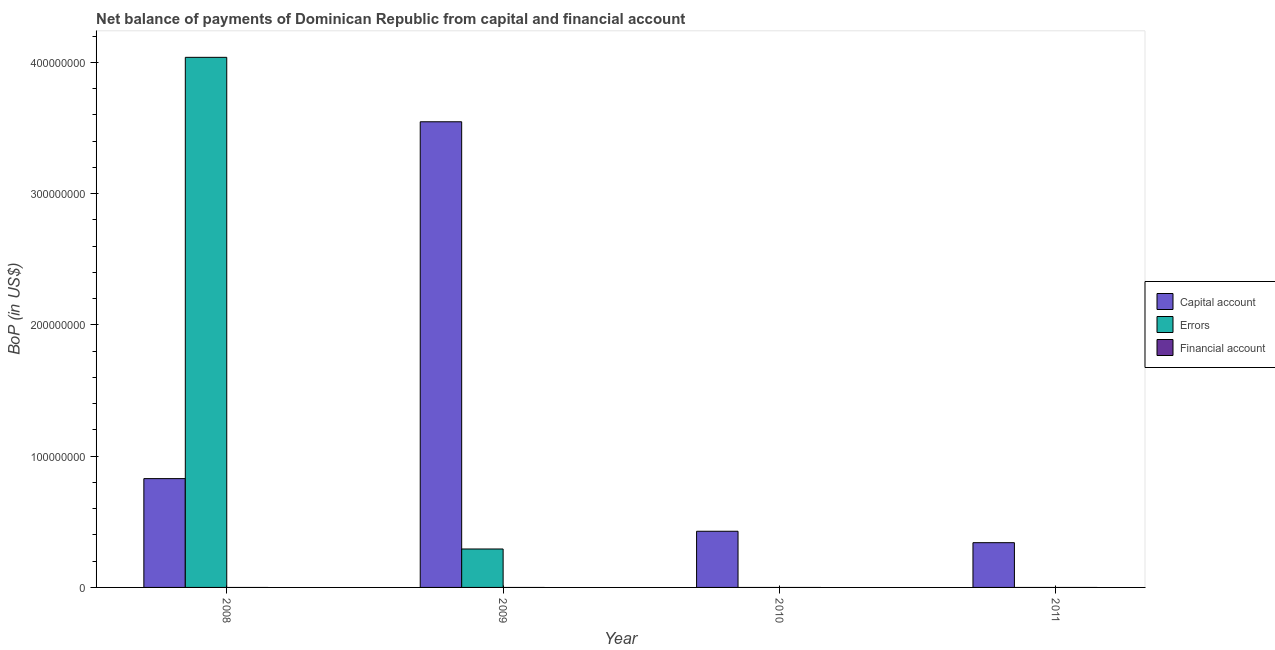How many different coloured bars are there?
Make the answer very short. 2. How many bars are there on the 1st tick from the right?
Your answer should be compact. 1. What is the label of the 3rd group of bars from the left?
Provide a succinct answer. 2010. In how many cases, is the number of bars for a given year not equal to the number of legend labels?
Your answer should be compact. 4. Across all years, what is the maximum amount of errors?
Keep it short and to the point. 4.04e+08. Across all years, what is the minimum amount of errors?
Keep it short and to the point. 0. What is the total amount of financial account in the graph?
Provide a short and direct response. 0. What is the difference between the amount of net capital account in 2008 and that in 2010?
Keep it short and to the point. 4.01e+07. What is the difference between the amount of errors in 2011 and the amount of net capital account in 2009?
Your response must be concise. -2.93e+07. What is the average amount of errors per year?
Make the answer very short. 1.08e+08. What is the ratio of the amount of net capital account in 2010 to that in 2011?
Make the answer very short. 1.26. Is the amount of net capital account in 2008 less than that in 2011?
Your response must be concise. No. Is the difference between the amount of net capital account in 2008 and 2009 greater than the difference between the amount of errors in 2008 and 2009?
Keep it short and to the point. No. What is the difference between the highest and the second highest amount of net capital account?
Offer a very short reply. 2.72e+08. What is the difference between the highest and the lowest amount of net capital account?
Provide a succinct answer. 3.21e+08. In how many years, is the amount of errors greater than the average amount of errors taken over all years?
Provide a short and direct response. 1. Is the sum of the amount of net capital account in 2010 and 2011 greater than the maximum amount of financial account across all years?
Your response must be concise. No. How many bars are there?
Offer a terse response. 6. How many years are there in the graph?
Offer a very short reply. 4. Where does the legend appear in the graph?
Offer a very short reply. Center right. What is the title of the graph?
Offer a terse response. Net balance of payments of Dominican Republic from capital and financial account. What is the label or title of the X-axis?
Your answer should be compact. Year. What is the label or title of the Y-axis?
Your response must be concise. BoP (in US$). What is the BoP (in US$) of Capital account in 2008?
Give a very brief answer. 8.29e+07. What is the BoP (in US$) in Errors in 2008?
Ensure brevity in your answer.  4.04e+08. What is the BoP (in US$) of Capital account in 2009?
Offer a terse response. 3.55e+08. What is the BoP (in US$) in Errors in 2009?
Make the answer very short. 2.93e+07. What is the BoP (in US$) of Capital account in 2010?
Keep it short and to the point. 4.28e+07. What is the BoP (in US$) in Errors in 2010?
Give a very brief answer. 0. What is the BoP (in US$) of Capital account in 2011?
Offer a very short reply. 3.41e+07. What is the BoP (in US$) in Financial account in 2011?
Ensure brevity in your answer.  0. Across all years, what is the maximum BoP (in US$) in Capital account?
Offer a very short reply. 3.55e+08. Across all years, what is the maximum BoP (in US$) in Errors?
Your response must be concise. 4.04e+08. Across all years, what is the minimum BoP (in US$) in Capital account?
Keep it short and to the point. 3.41e+07. Across all years, what is the minimum BoP (in US$) in Errors?
Provide a succinct answer. 0. What is the total BoP (in US$) of Capital account in the graph?
Keep it short and to the point. 5.15e+08. What is the total BoP (in US$) of Errors in the graph?
Provide a short and direct response. 4.33e+08. What is the total BoP (in US$) of Financial account in the graph?
Offer a terse response. 0. What is the difference between the BoP (in US$) of Capital account in 2008 and that in 2009?
Your response must be concise. -2.72e+08. What is the difference between the BoP (in US$) of Errors in 2008 and that in 2009?
Your answer should be very brief. 3.75e+08. What is the difference between the BoP (in US$) of Capital account in 2008 and that in 2010?
Your answer should be very brief. 4.01e+07. What is the difference between the BoP (in US$) in Capital account in 2008 and that in 2011?
Provide a succinct answer. 4.88e+07. What is the difference between the BoP (in US$) of Capital account in 2009 and that in 2010?
Offer a terse response. 3.12e+08. What is the difference between the BoP (in US$) of Capital account in 2009 and that in 2011?
Keep it short and to the point. 3.21e+08. What is the difference between the BoP (in US$) of Capital account in 2010 and that in 2011?
Ensure brevity in your answer.  8.70e+06. What is the difference between the BoP (in US$) of Capital account in 2008 and the BoP (in US$) of Errors in 2009?
Make the answer very short. 5.36e+07. What is the average BoP (in US$) in Capital account per year?
Give a very brief answer. 1.29e+08. What is the average BoP (in US$) in Errors per year?
Keep it short and to the point. 1.08e+08. What is the average BoP (in US$) in Financial account per year?
Provide a succinct answer. 0. In the year 2008, what is the difference between the BoP (in US$) in Capital account and BoP (in US$) in Errors?
Make the answer very short. -3.21e+08. In the year 2009, what is the difference between the BoP (in US$) in Capital account and BoP (in US$) in Errors?
Give a very brief answer. 3.26e+08. What is the ratio of the BoP (in US$) of Capital account in 2008 to that in 2009?
Give a very brief answer. 0.23. What is the ratio of the BoP (in US$) of Errors in 2008 to that in 2009?
Provide a short and direct response. 13.79. What is the ratio of the BoP (in US$) in Capital account in 2008 to that in 2010?
Give a very brief answer. 1.94. What is the ratio of the BoP (in US$) of Capital account in 2008 to that in 2011?
Your answer should be very brief. 2.43. What is the ratio of the BoP (in US$) of Capital account in 2009 to that in 2010?
Provide a short and direct response. 8.29. What is the ratio of the BoP (in US$) of Capital account in 2009 to that in 2011?
Your answer should be compact. 10.4. What is the ratio of the BoP (in US$) of Capital account in 2010 to that in 2011?
Your answer should be very brief. 1.26. What is the difference between the highest and the second highest BoP (in US$) of Capital account?
Your answer should be compact. 2.72e+08. What is the difference between the highest and the lowest BoP (in US$) in Capital account?
Provide a short and direct response. 3.21e+08. What is the difference between the highest and the lowest BoP (in US$) of Errors?
Provide a succinct answer. 4.04e+08. 